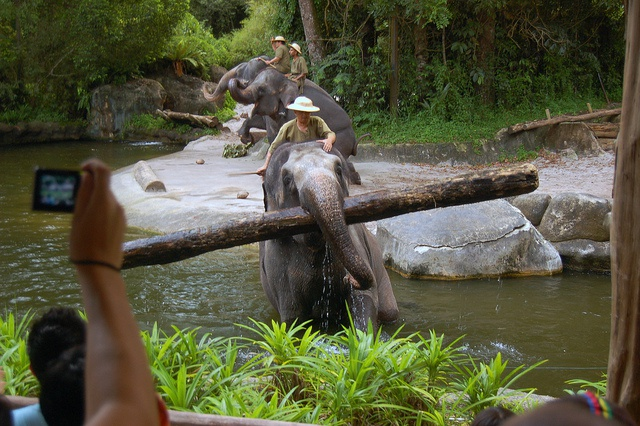Describe the objects in this image and their specific colors. I can see elephant in darkgreen, black, gray, darkgray, and lightgray tones, people in darkgreen, maroon, black, and gray tones, people in darkgreen, black, and blue tones, elephant in darkgreen, gray, black, and darkgray tones, and cell phone in darkgreen, black, blue, and darkblue tones in this image. 